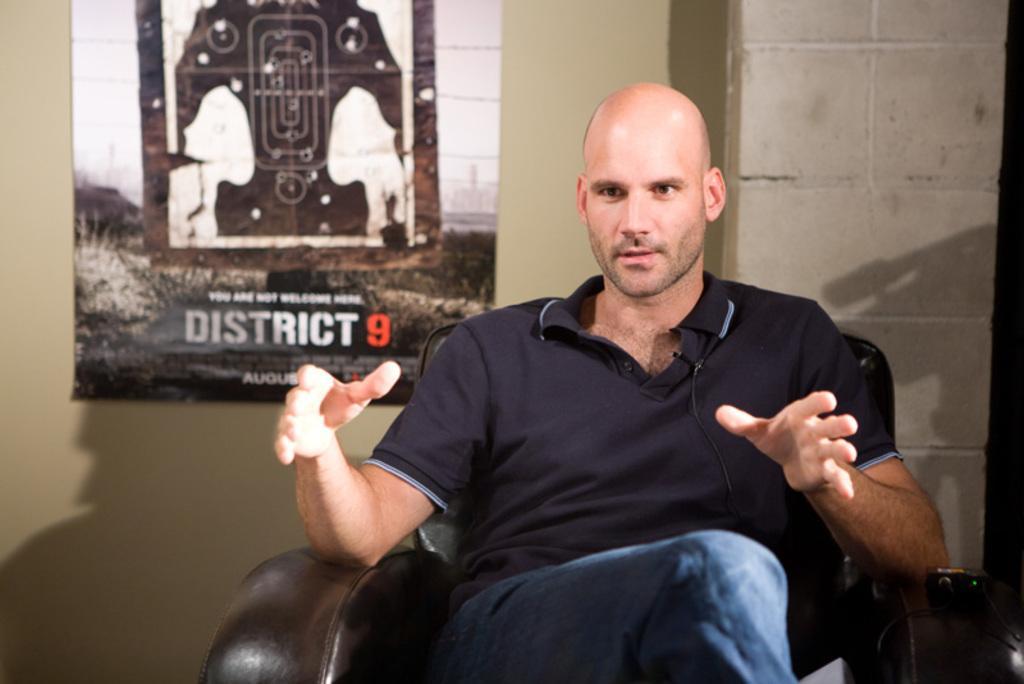Could you give a brief overview of what you see in this image? here we see a man seated on the chair and speaking and we see a poster on the wall back of him 